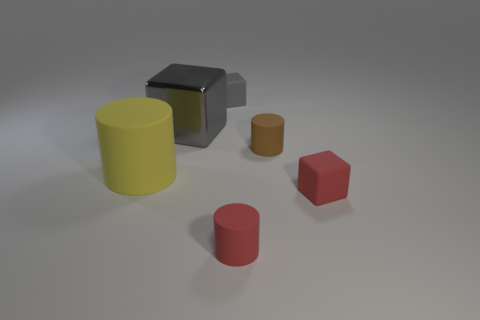Add 1 big metal cubes. How many objects exist? 7 Subtract 1 brown cylinders. How many objects are left? 5 Subtract all tiny brown objects. Subtract all small brown matte cylinders. How many objects are left? 4 Add 3 blocks. How many blocks are left? 6 Add 3 large gray metal objects. How many large gray metal objects exist? 4 